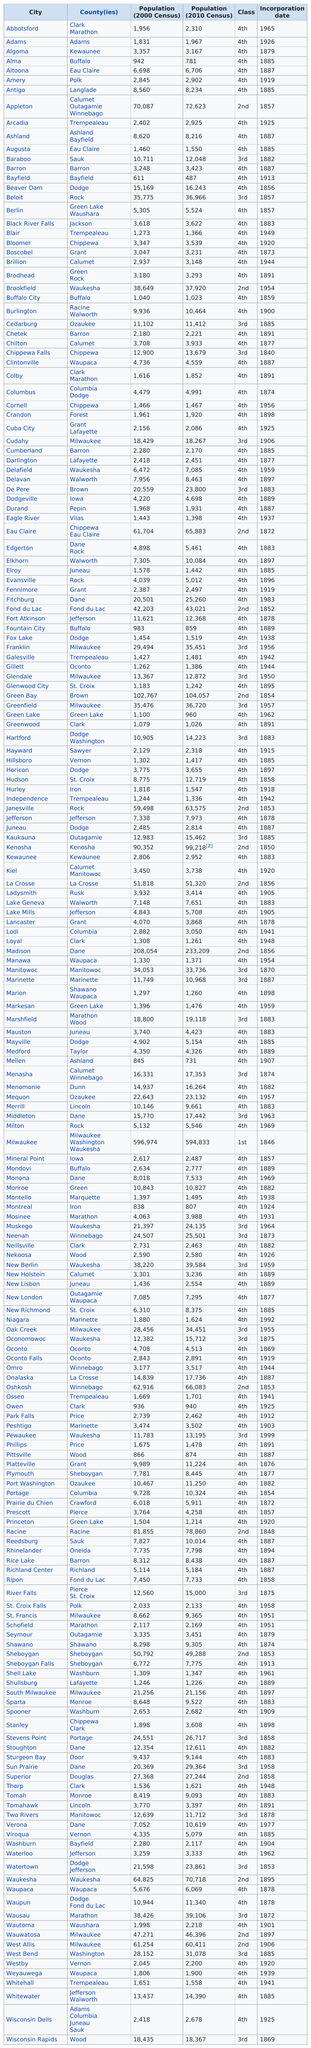Point out several critical features in this image. The city with the highest population growth from 2000 to 2010 was Madison. The county has two cities named Altoona and Augusta, as well as Eau Claire. The state of Wisconsin contains 190 cities. Milwaukee had the highest population in the 2010 census. The most populous city in the state of Wisconsin, based on the 2010 census, is Milwaukee. 